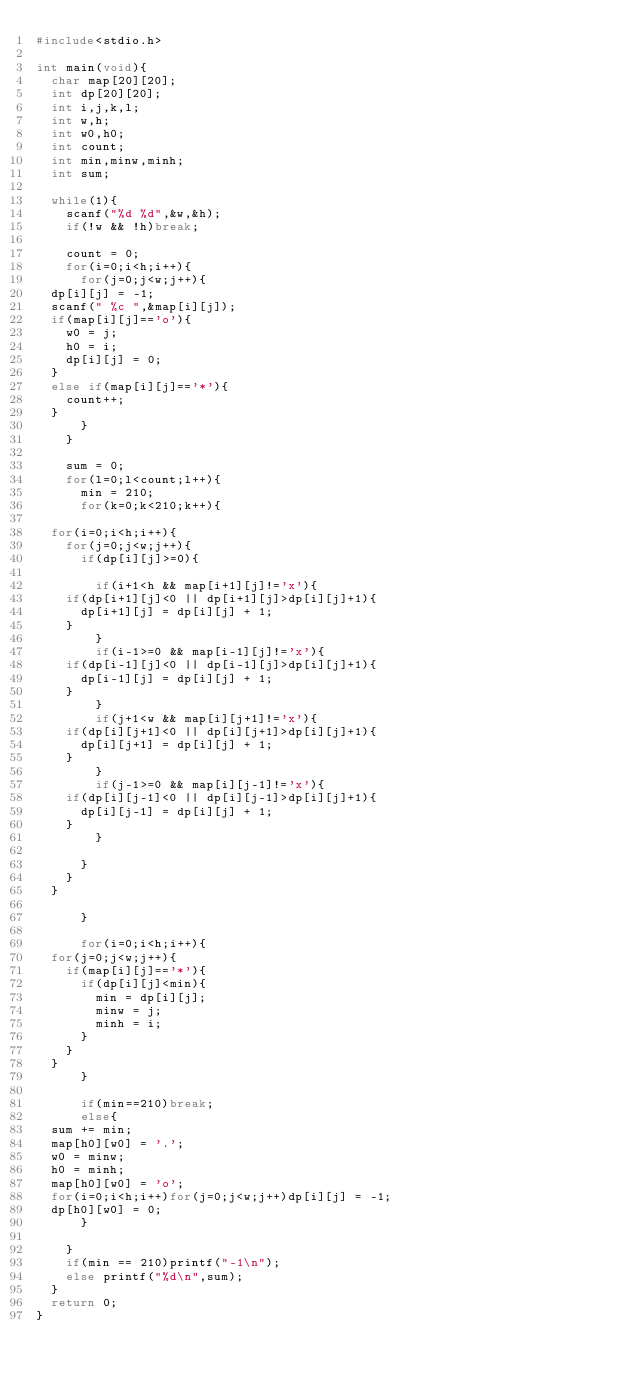Convert code to text. <code><loc_0><loc_0><loc_500><loc_500><_C_>#include<stdio.h>

int main(void){
  char map[20][20];
  int dp[20][20];
  int i,j,k,l;
  int w,h;
  int w0,h0;
  int count;
  int min,minw,minh;
  int sum;

  while(1){
    scanf("%d %d",&w,&h);
    if(!w && !h)break;

    count = 0;
    for(i=0;i<h;i++){
      for(j=0;j<w;j++){
	dp[i][j] = -1;
	scanf(" %c ",&map[i][j]);
	if(map[i][j]=='o'){
	  w0 = j;
	  h0 = i;
	  dp[i][j] = 0;
	}
	else if(map[i][j]=='*'){
	  count++;
	} 
      }
    }

    sum = 0;
    for(l=0;l<count;l++){
      min = 210;
      for(k=0;k<210;k++){

	for(i=0;i<h;i++){
	  for(j=0;j<w;j++){
	    if(dp[i][j]>=0){
	      
	      if(i+1<h && map[i+1][j]!='x'){
		if(dp[i+1][j]<0 || dp[i+1][j]>dp[i][j]+1){
		  dp[i+1][j] = dp[i][j] + 1;
		}
	      }
	      if(i-1>=0 && map[i-1][j]!='x'){
		if(dp[i-1][j]<0 || dp[i-1][j]>dp[i][j]+1){
		  dp[i-1][j] = dp[i][j] + 1;
		}
	      }	
	      if(j+1<w && map[i][j+1]!='x'){
		if(dp[i][j+1]<0 || dp[i][j+1]>dp[i][j]+1){
		  dp[i][j+1] = dp[i][j] + 1;
		}
	      }
	      if(j-1>=0 && map[i][j-1]!='x'){
		if(dp[i][j-1]<0 || dp[i][j-1]>dp[i][j]+1){
		  dp[i][j-1] = dp[i][j] + 1;
		}
	      }

	    }
	  }
	}

      }

      for(i=0;i<h;i++){
	for(j=0;j<w;j++){
	  if(map[i][j]=='*'){
	    if(dp[i][j]<min){
	      min = dp[i][j];
	      minw = j;
	      minh = i;
	    }
	  }
	}
      }

      if(min==210)break;
      else{
	sum += min;
	map[h0][w0] = '.';
	w0 = minw;
	h0 = minh;
	map[h0][w0] = 'o';
	for(i=0;i<h;i++)for(j=0;j<w;j++)dp[i][j] = -1;
	dp[h0][w0] = 0;
      }

    }
    if(min == 210)printf("-1\n");
    else printf("%d\n",sum);
  }
  return 0;
}</code> 